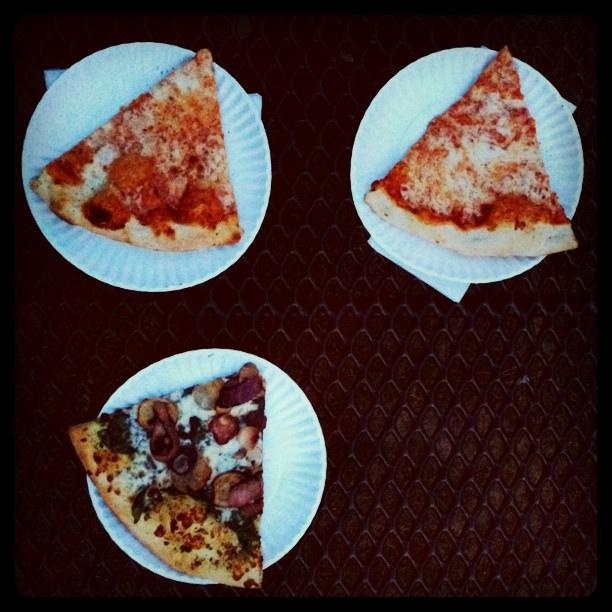How many plate are there?
Short answer required. 3. How many slices?
Short answer required. 3. What kind of mushrooms is on the bottom slice of pizza?
Quick response, please. Portabella. Does all the pizza have the same toppings?
Keep it brief. No. 